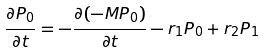Convert formula to latex. <formula><loc_0><loc_0><loc_500><loc_500>\frac { \partial P _ { 0 } } { \partial t } = - \frac { \partial ( - M P _ { 0 } ) } { \partial t } - r _ { 1 } P _ { 0 } + r _ { 2 } P _ { 1 }</formula> 